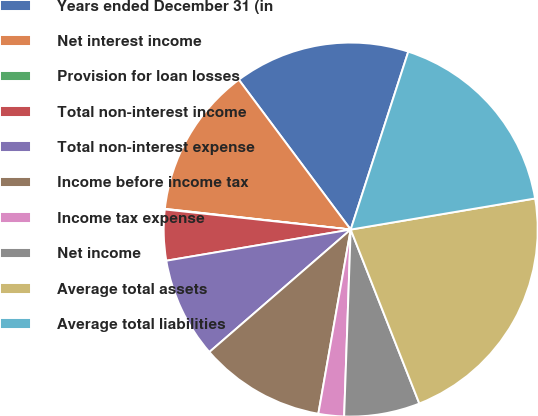Convert chart. <chart><loc_0><loc_0><loc_500><loc_500><pie_chart><fcel>Years ended December 31 (in<fcel>Net interest income<fcel>Provision for loan losses<fcel>Total non-interest income<fcel>Total non-interest expense<fcel>Income before income tax<fcel>Income tax expense<fcel>Net income<fcel>Average total assets<fcel>Average total liabilities<nl><fcel>15.19%<fcel>13.03%<fcel>0.05%<fcel>4.38%<fcel>8.7%<fcel>10.87%<fcel>2.21%<fcel>6.54%<fcel>21.68%<fcel>17.36%<nl></chart> 